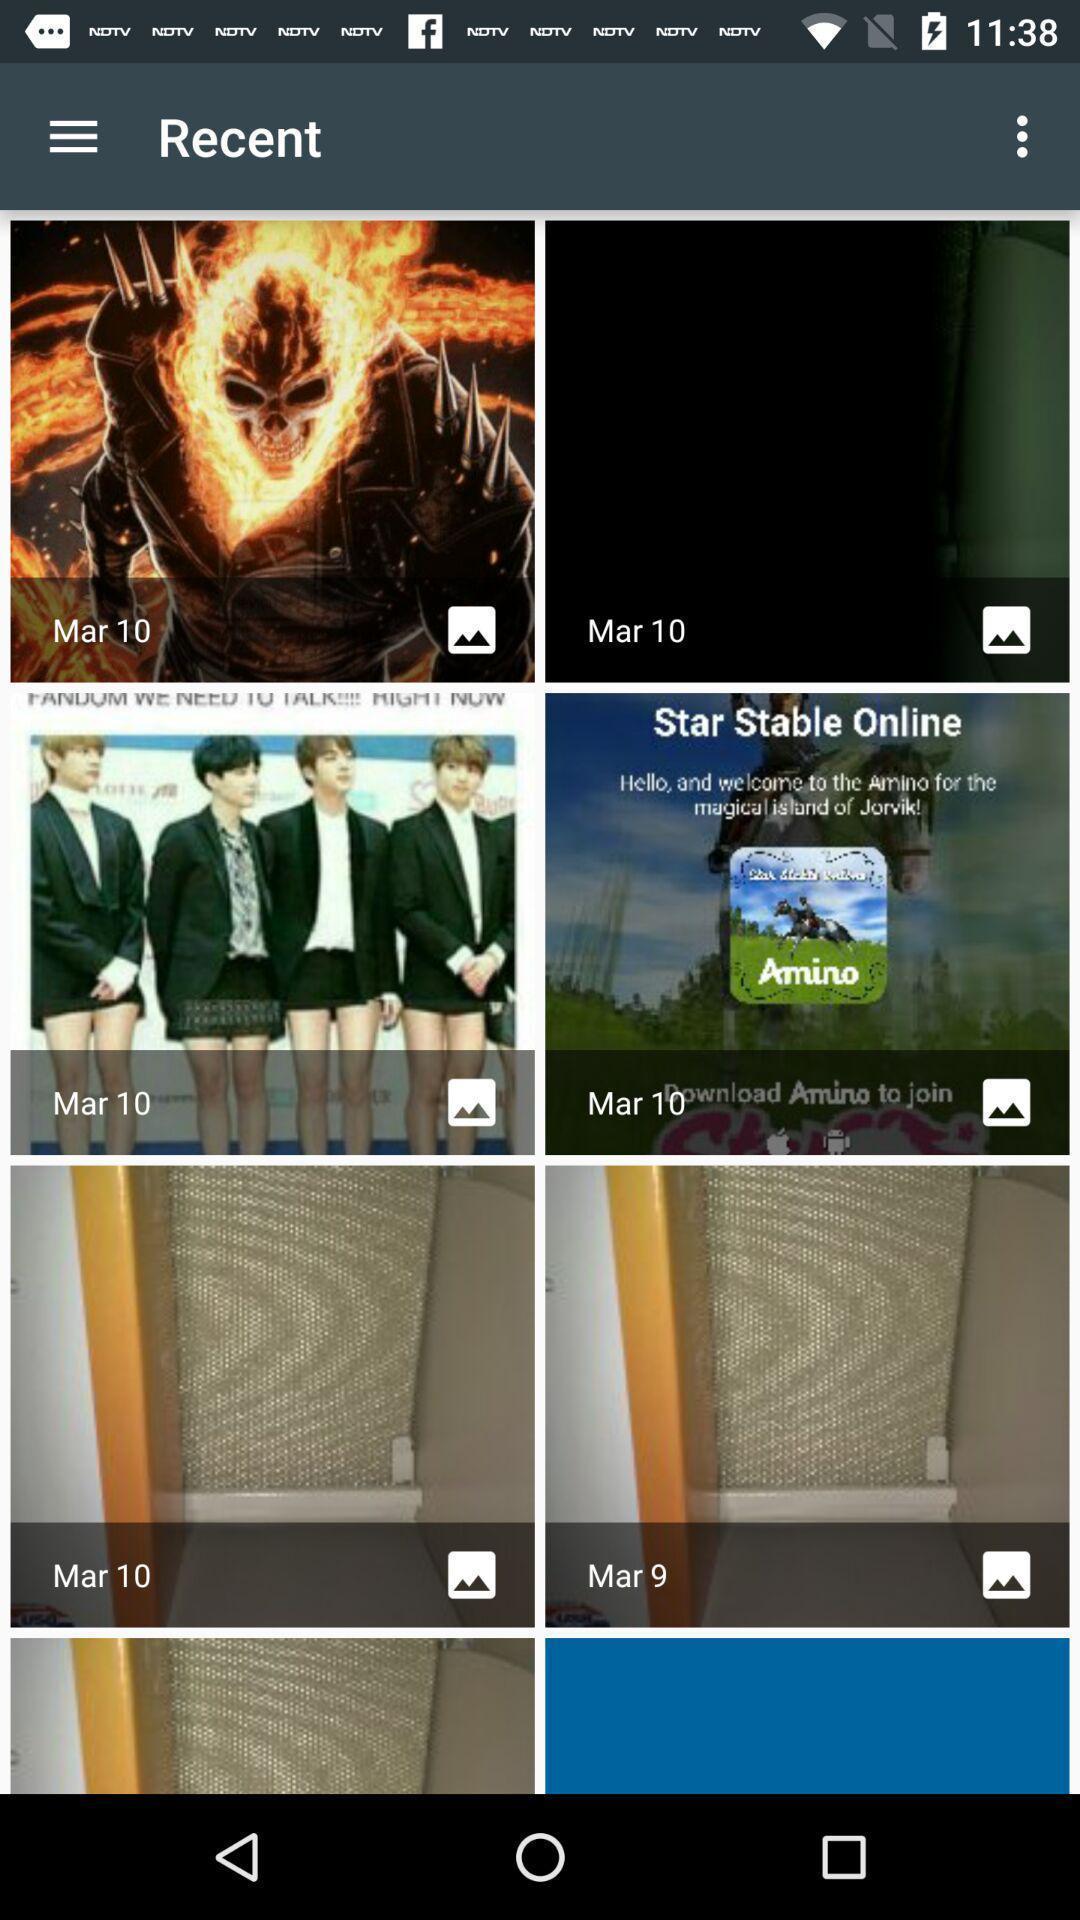Provide a description of this screenshot. Screen showing images. 